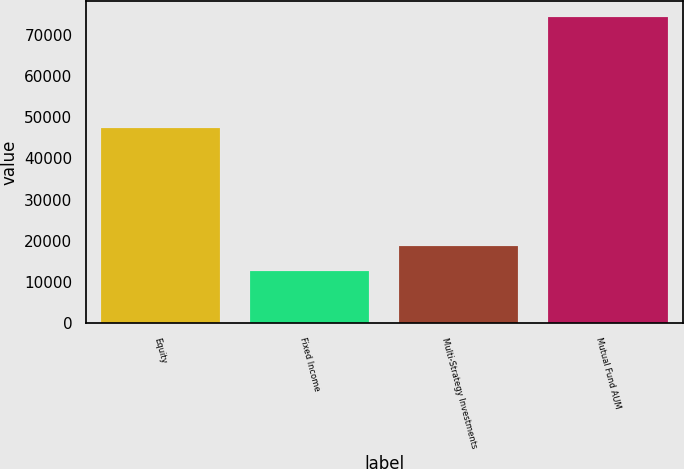Convert chart to OTSL. <chart><loc_0><loc_0><loc_500><loc_500><bar_chart><fcel>Equity<fcel>Fixed Income<fcel>Multi-Strategy Investments<fcel>Mutual Fund AUM<nl><fcel>47369<fcel>12625<fcel>18803.8<fcel>74413<nl></chart> 